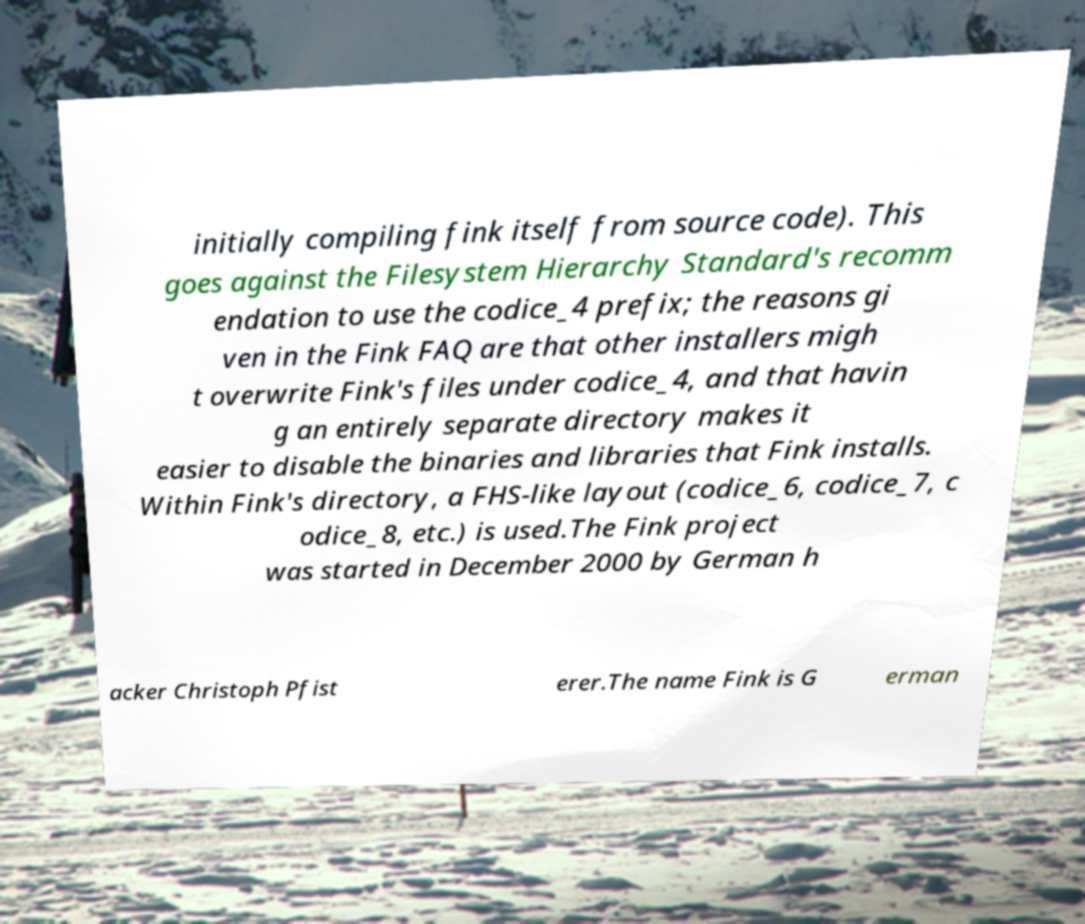Can you read and provide the text displayed in the image?This photo seems to have some interesting text. Can you extract and type it out for me? initially compiling fink itself from source code). This goes against the Filesystem Hierarchy Standard's recomm endation to use the codice_4 prefix; the reasons gi ven in the Fink FAQ are that other installers migh t overwrite Fink's files under codice_4, and that havin g an entirely separate directory makes it easier to disable the binaries and libraries that Fink installs. Within Fink's directory, a FHS-like layout (codice_6, codice_7, c odice_8, etc.) is used.The Fink project was started in December 2000 by German h acker Christoph Pfist erer.The name Fink is G erman 